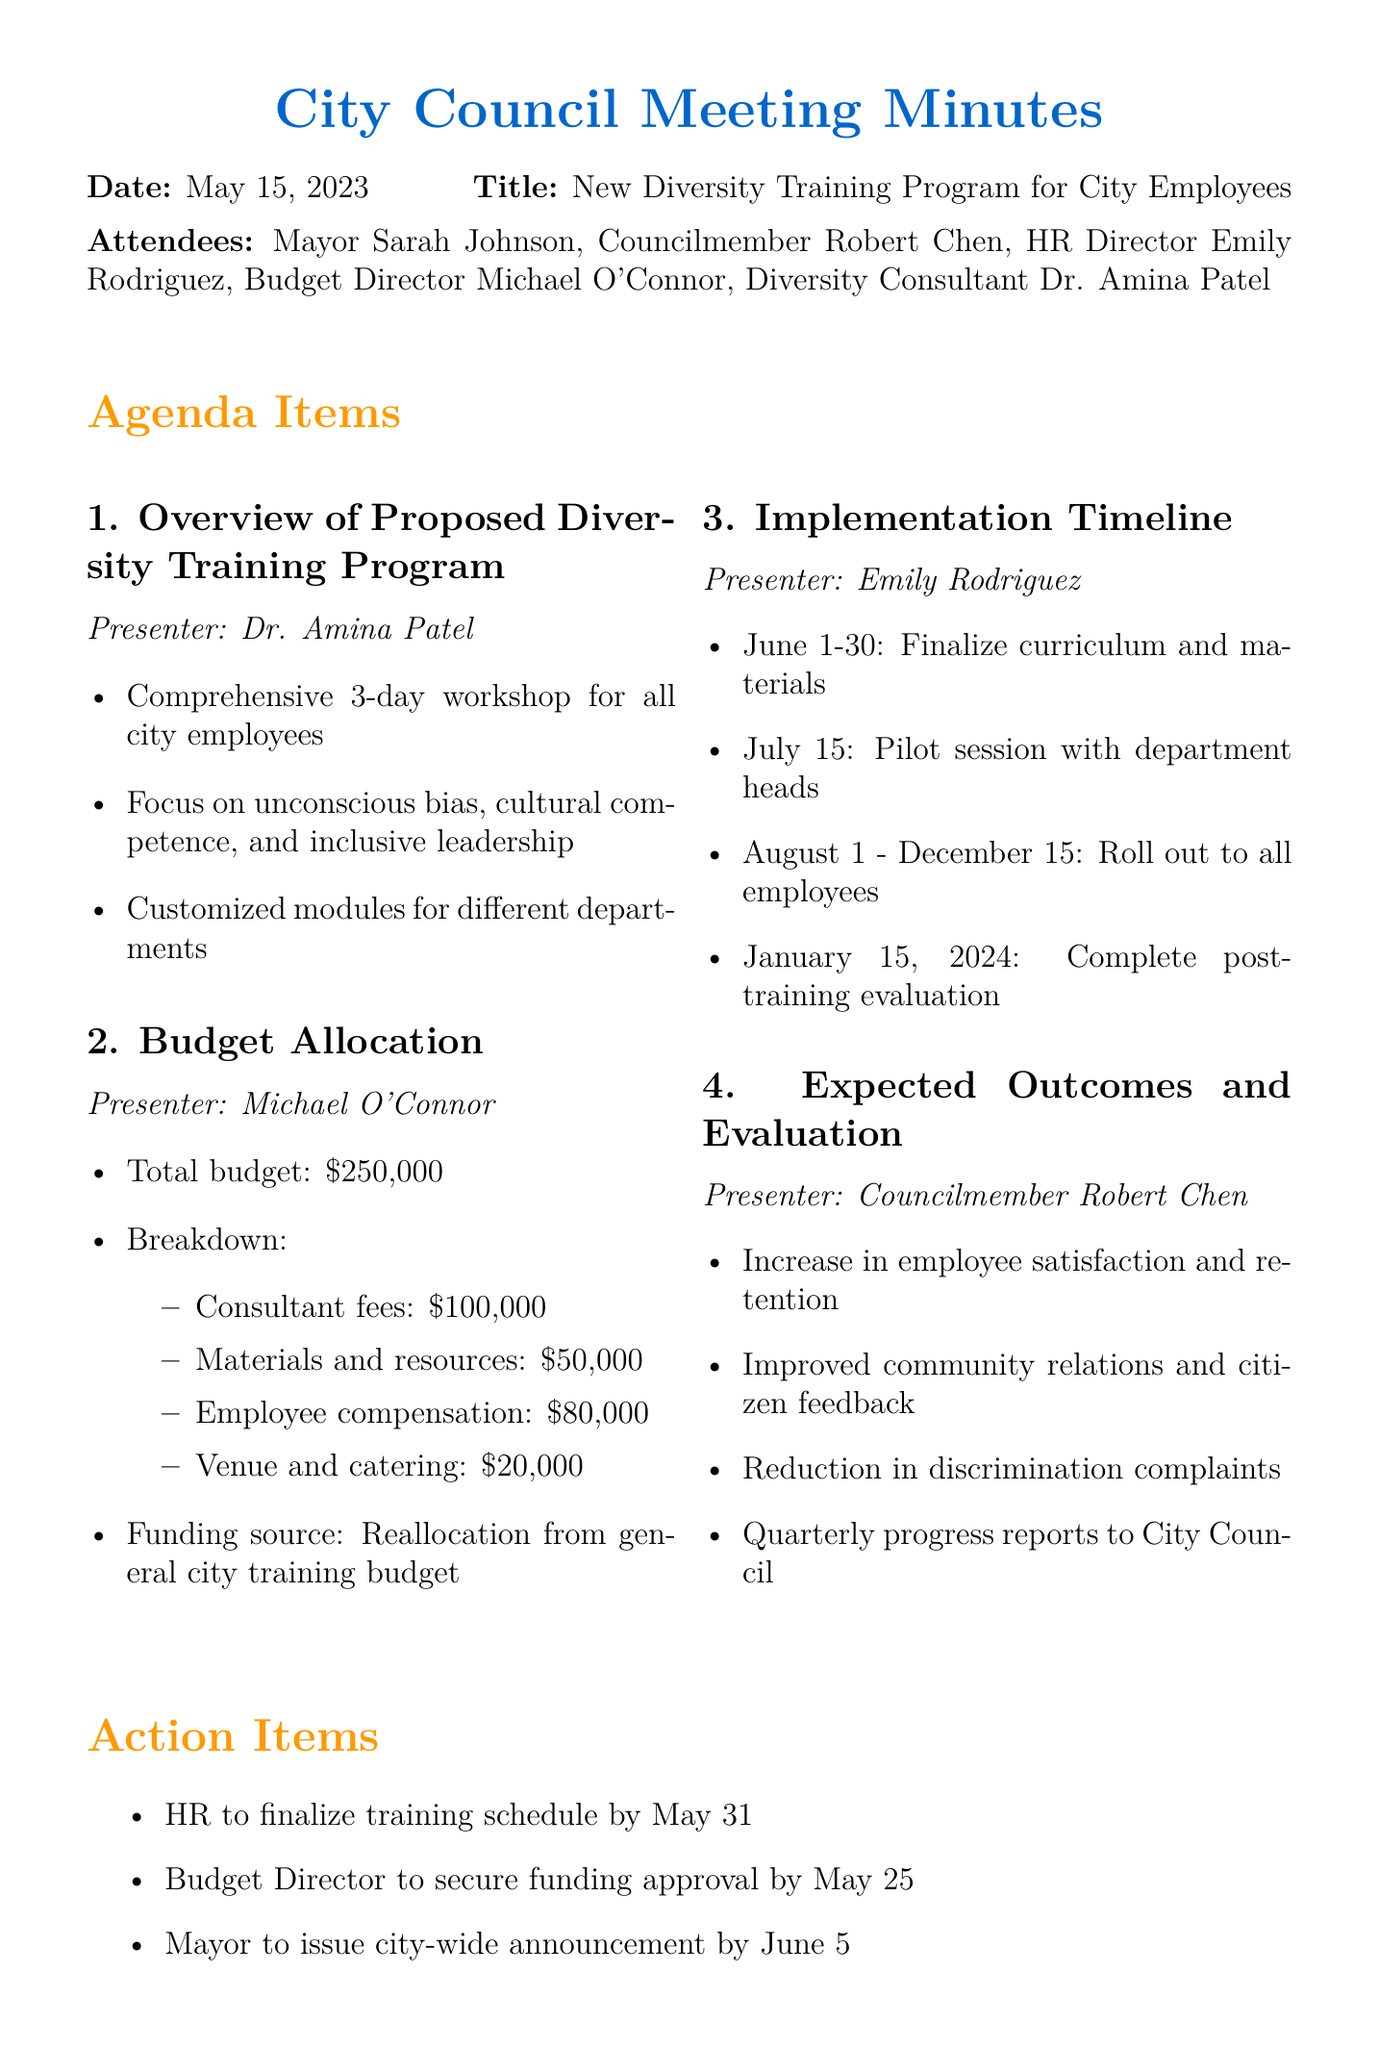What is the date of the meeting? The date of the meeting is provided in the document.
Answer: May 15, 2023 Who presented the budget allocation? The document lists the presenters for each agenda item, including the budget allocation.
Answer: Michael O'Connor How much is the budget allocated for materials and resources? The budget details provide a breakdown of costs, including materials and resources.
Answer: $50,000 What is the timeline for the pilot session? The timeline outlines specific dates for various training activities, including the pilot session.
Answer: July 15 What percentage of the total budget is allocated for consultant fees? The budget breakdown shows the allocation and can be used to calculate the percentage.
Answer: 40% What is the expected outcome related to community relations? The outcomes section specifies the benefits expected from the training programs, mentioning community relations.
Answer: Improved community relations and citizen feedback Which department is responsible for finalizing the training schedule? The action items specify responsible parties for various tasks, including the training schedule.
Answer: HR When will the post-training evaluation be completed? The timeline specifies when the post-training evaluation will be conducted.
Answer: January 15, 2024 What type of workshop is proposed for city employees? The overview provides information on the type of training program being discussed.
Answer: Comprehensive 3-day workshop 